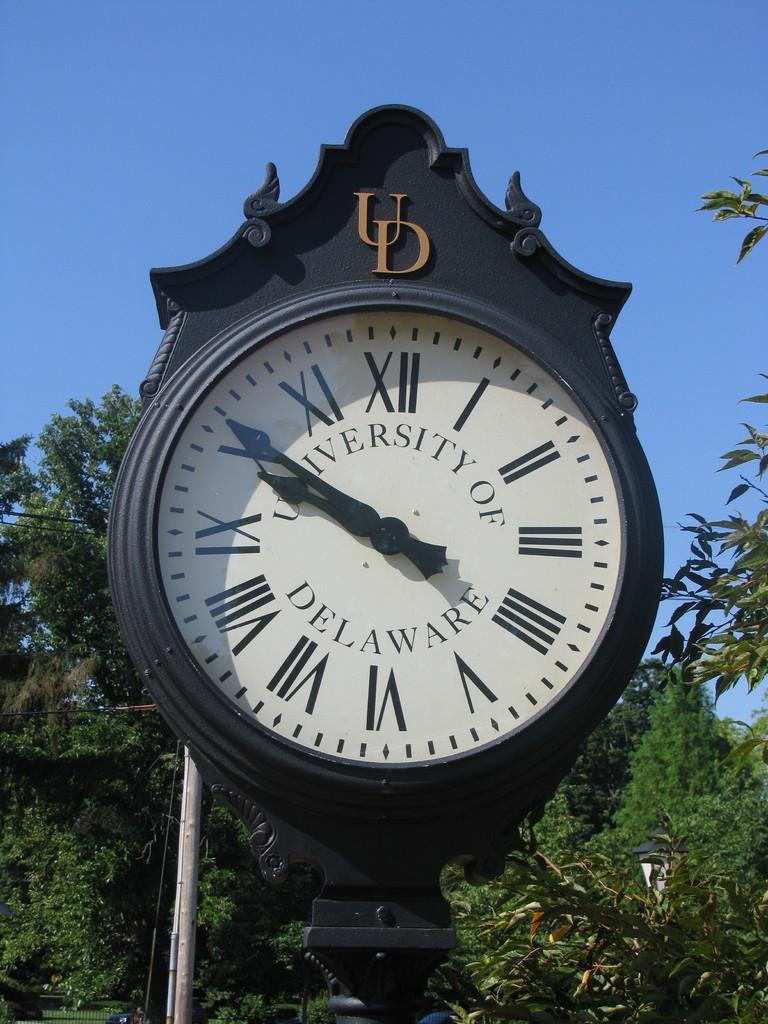Provide a one-sentence caption for the provided image. University of Delawate black and white clock with roman numerals. 